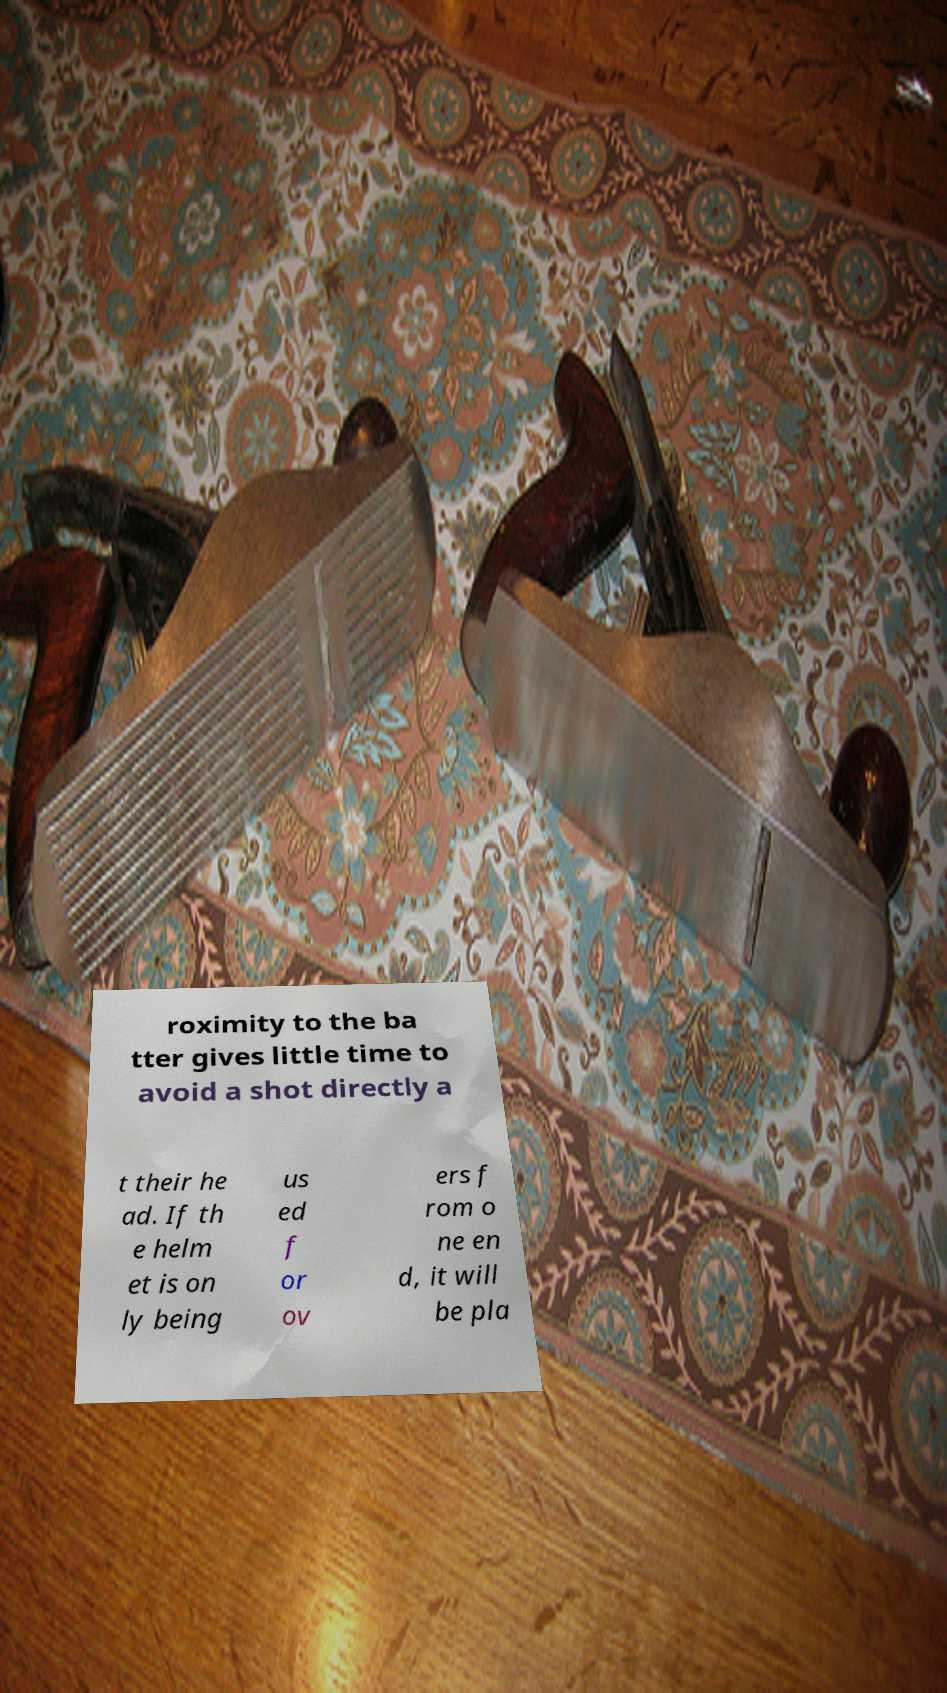Could you assist in decoding the text presented in this image and type it out clearly? roximity to the ba tter gives little time to avoid a shot directly a t their he ad. If th e helm et is on ly being us ed f or ov ers f rom o ne en d, it will be pla 